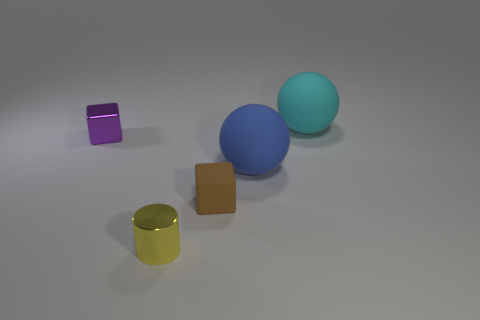What material is the other small object that is the same shape as the tiny brown matte object?
Give a very brief answer. Metal. There is a small brown rubber block that is in front of the rubber sphere to the left of the big cyan rubber object; are there any cyan objects on the right side of it?
Make the answer very short. Yes. There is a rubber thing that is behind the big blue sphere; is its shape the same as the big thing in front of the tiny metallic cube?
Your answer should be very brief. Yes. Are there more tiny metallic objects left of the metal cylinder than small blue matte objects?
Provide a succinct answer. Yes. How many objects are green rubber cylinders or big rubber things?
Your answer should be very brief. 2. The small rubber thing is what color?
Offer a very short reply. Brown. There is a rubber block; are there any tiny cubes left of it?
Offer a very short reply. Yes. The large sphere that is in front of the big matte object that is behind the purple object to the left of the yellow object is what color?
Provide a short and direct response. Blue. What number of things are behind the yellow object and on the right side of the purple metal block?
Your answer should be compact. 3. What number of cylinders are large cyan objects or small brown rubber things?
Provide a short and direct response. 0. 